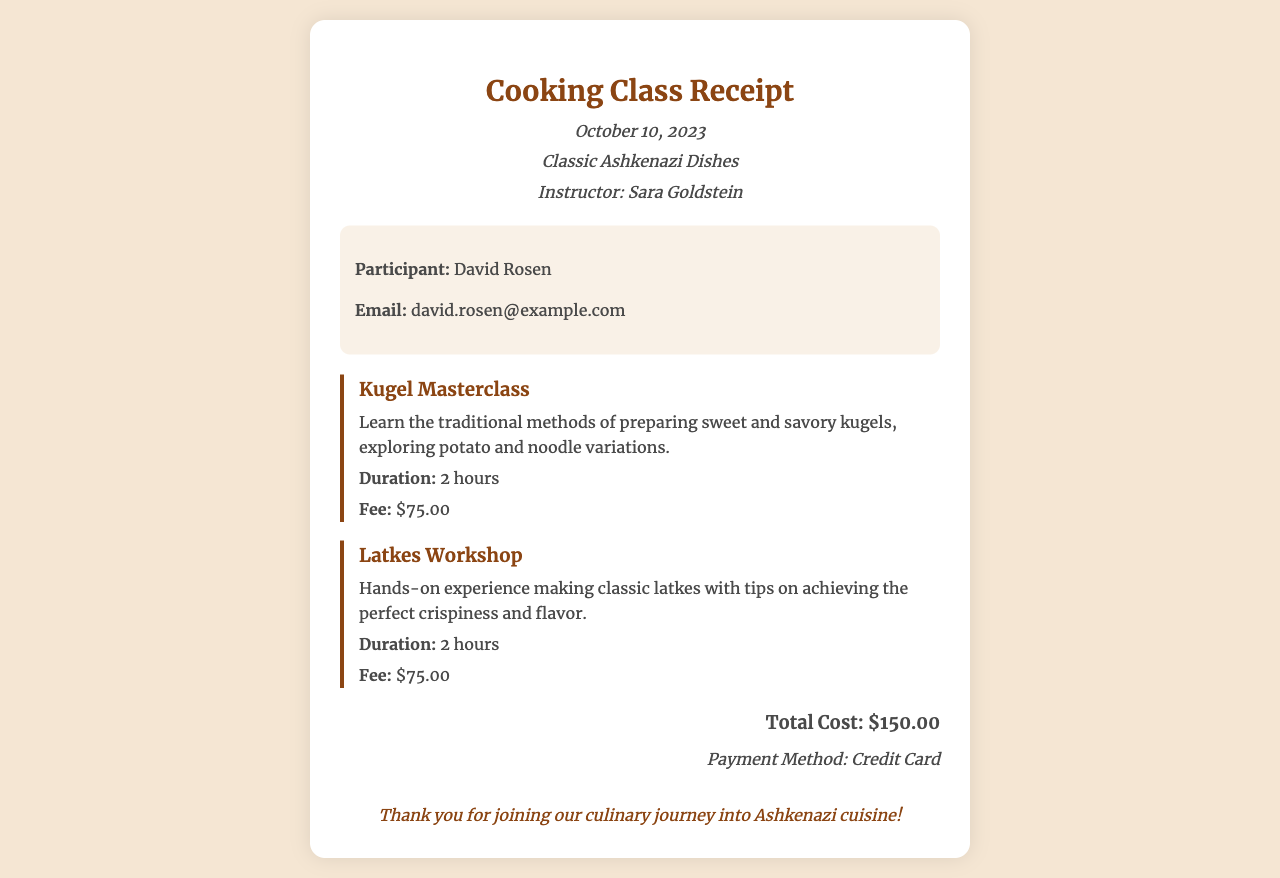What is the name of the instructor? The instructor's name is mentioned in the header section of the document.
Answer: Sara Goldstein What is the date of the cooking class? The date of the cooking class is specified in the header section of the document.
Answer: October 10, 2023 What is the fee for the Kugel Masterclass? The fee for the Kugel Masterclass is listed under the class details section.
Answer: $75.00 How long is the Latkes Workshop? The duration of the Latkes Workshop is mentioned in the class details section.
Answer: 2 hours What is the total cost of the classes? The total cost is summarized at the bottom of the document.
Answer: $150.00 What payment method was used? The payment method is specified at the bottom of the receipt.
Answer: Credit Card What types of kugels are mentioned in the masterclass? The description of the Kugel Masterclass includes the types of kugels covered.
Answer: sweet and savory Who is the participant? The participant's name is provided in the participant info section.
Answer: David Rosen What culinary tradition is the focus of the cooking class? The culinary tradition is indicated in the document title and header.
Answer: Ashkenazi cuisine 